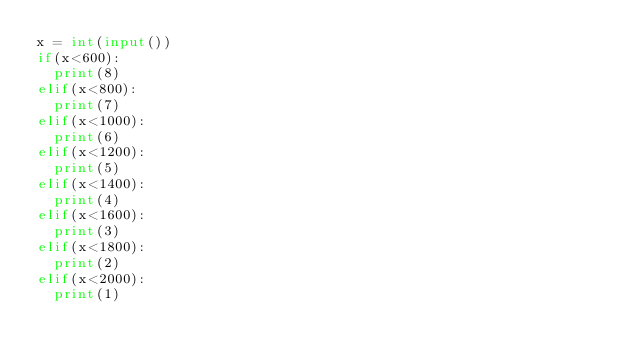<code> <loc_0><loc_0><loc_500><loc_500><_Python_>x = int(input())
if(x<600):
  print(8)
elif(x<800):
  print(7)
elif(x<1000):
  print(6)
elif(x<1200):
  print(5)
elif(x<1400):
  print(4)
elif(x<1600):
  print(3)
elif(x<1800):
  print(2)
elif(x<2000):
  print(1)</code> 